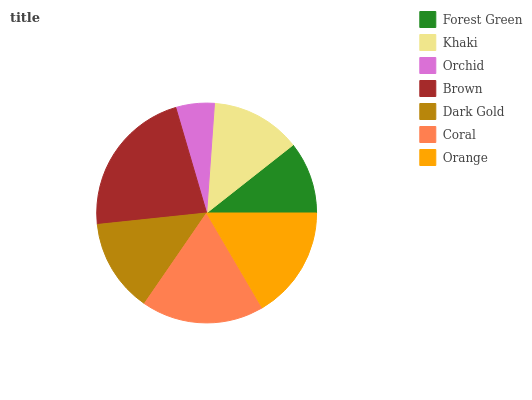Is Orchid the minimum?
Answer yes or no. Yes. Is Brown the maximum?
Answer yes or no. Yes. Is Khaki the minimum?
Answer yes or no. No. Is Khaki the maximum?
Answer yes or no. No. Is Khaki greater than Forest Green?
Answer yes or no. Yes. Is Forest Green less than Khaki?
Answer yes or no. Yes. Is Forest Green greater than Khaki?
Answer yes or no. No. Is Khaki less than Forest Green?
Answer yes or no. No. Is Dark Gold the high median?
Answer yes or no. Yes. Is Dark Gold the low median?
Answer yes or no. Yes. Is Orchid the high median?
Answer yes or no. No. Is Orchid the low median?
Answer yes or no. No. 